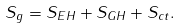Convert formula to latex. <formula><loc_0><loc_0><loc_500><loc_500>S _ { g } = S _ { E H } + S _ { G H } + S _ { c t } .</formula> 